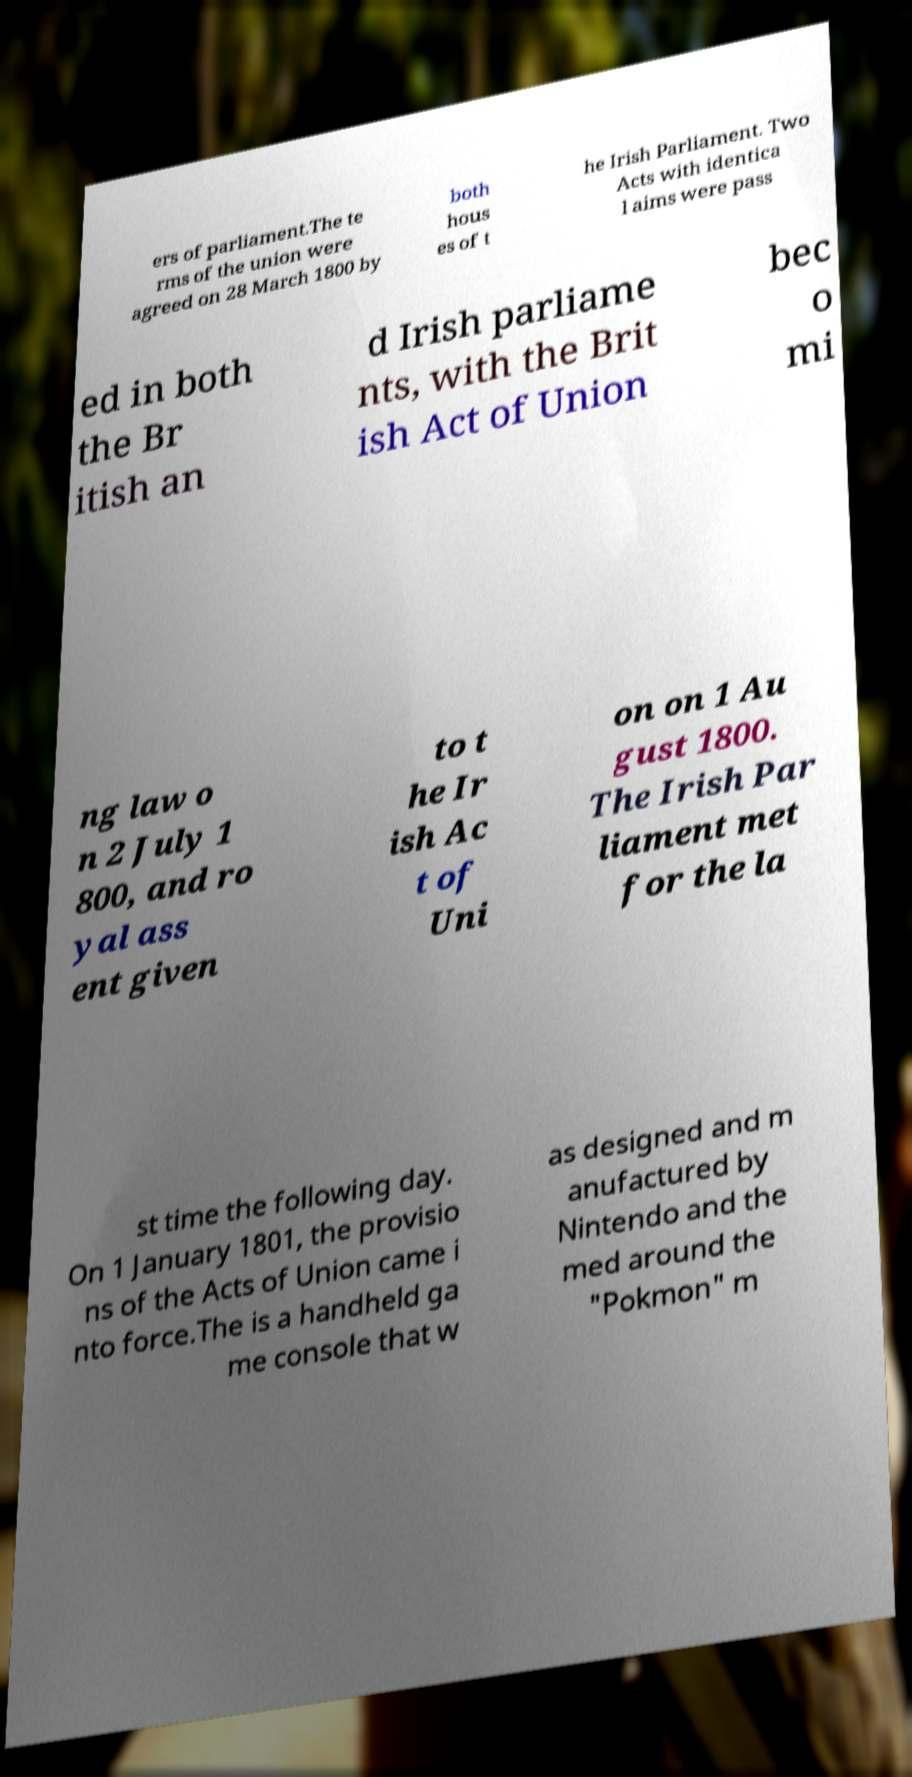Can you accurately transcribe the text from the provided image for me? ers of parliament.The te rms of the union were agreed on 28 March 1800 by both hous es of t he Irish Parliament. Two Acts with identica l aims were pass ed in both the Br itish an d Irish parliame nts, with the Brit ish Act of Union bec o mi ng law o n 2 July 1 800, and ro yal ass ent given to t he Ir ish Ac t of Uni on on 1 Au gust 1800. The Irish Par liament met for the la st time the following day. On 1 January 1801, the provisio ns of the Acts of Union came i nto force.The is a handheld ga me console that w as designed and m anufactured by Nintendo and the med around the "Pokmon" m 